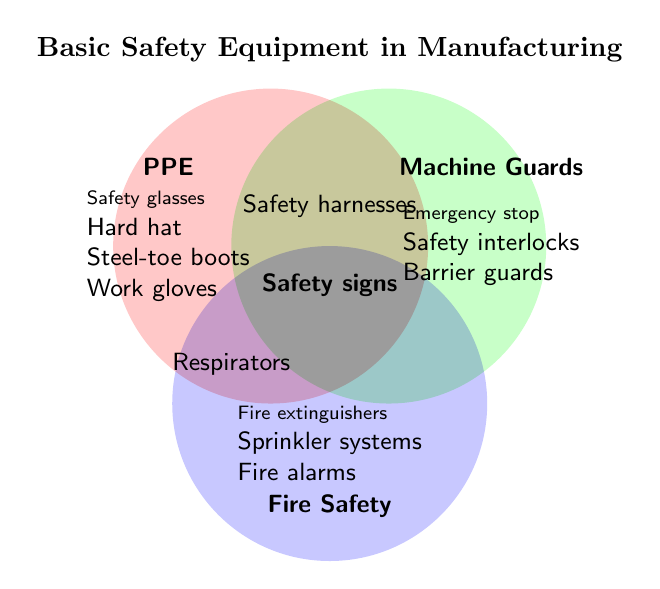What is the title of the Venn Diagram? Look for the text at the top of the figure. The title is often displayed prominently to indicate the main topic.
Answer: Basic Safety Equipment in Manufacturing Which category does "Steel-toe boots" belong to? Find "Steel-toe boots" and see which category it's listed under. It's grouped under PPE (Personal Protective Equipment).
Answer: PPE Which items are in the intersection of PPE and Fire Safety? Examine the overlapping areas of the circles representing PPE and Fire Safety and look for items listed there.
Answer: Respirators Do "Fire extinguishers" belong to more than one category? Check where "Fire extinguishers" is located. It is listed only under the Fire Safety category, not overlapping any other category.
Answer: No How many items belong to the category of Machine Guards? Count the items listed under the Machine Guards section of the diagram.
Answer: 3 Which category includes "Safety harnesses"? Look at the intersections for the entry "Safety harnesses." It's located where PPE and Machine Guards overlap.
Answer: Both PPE and Machine Guards What is unique about "Safety signs"? Find "Safety signs" and see which sections it overlaps. It's present in all three categories (PPE, Machine Guards, and Fire Safety). This makes it different from other items that don't span all categories.
Answer: Present in all categories What are the items listed under Fire Safety? Observe the section specifically labeled Fire Safety and list all items there.
Answer: Fire extinguishers, Sprinkler systems, Fire alarms Compare the item counts between PPE and Fire Safety. Which has more items? Count the items in both PPE and Fire Safety sections. PPE has 4 items, and Fire Safety has 3 items. PPE has more items.
Answer: PPE What is the common item between all three categories? Look at the very center of all overlapping sections for the shared item among PPE, Machine Guards, and Fire Safety.
Answer: Safety signs 